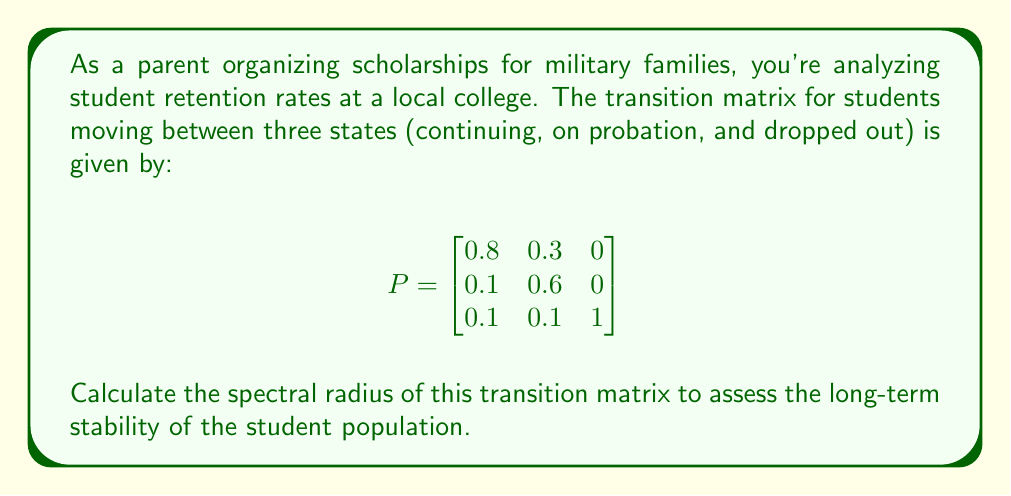Solve this math problem. To calculate the spectral radius of the transition matrix P, we need to follow these steps:

1) First, we need to find the eigenvalues of the matrix P. The characteristic equation is:

   $$det(P - \lambda I) = 0$$

2) Expanding this:

   $$\begin{vmatrix}
   0.8-\lambda & 0.3 & 0 \\
   0.1 & 0.6-\lambda & 0 \\
   0.1 & 0.1 & 1-\lambda
   \end{vmatrix} = 0$$

3) This gives us:

   $$(0.8-\lambda)(0.6-\lambda)(1-\lambda) - 0.1 \cdot 0.3 \cdot (1-\lambda) = 0$$

4) Simplifying:

   $$\lambda^3 - 2.4\lambda^2 + 1.51\lambda - 0.45 = 0$$

5) This cubic equation can be solved to find the eigenvalues. They are:

   $$\lambda_1 = 1, \lambda_2 \approx 0.9, \lambda_3 \approx 0.5$$

6) The spectral radius is the largest absolute value among these eigenvalues.

Therefore, the spectral radius is 1.
Answer: 1 